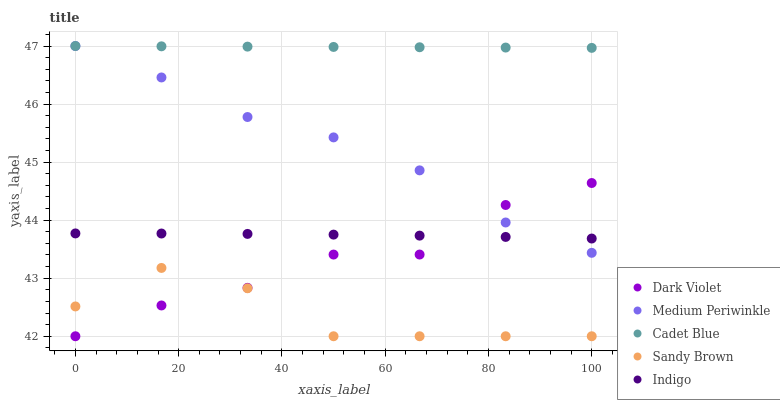Does Sandy Brown have the minimum area under the curve?
Answer yes or no. Yes. Does Cadet Blue have the maximum area under the curve?
Answer yes or no. Yes. Does Medium Periwinkle have the minimum area under the curve?
Answer yes or no. No. Does Medium Periwinkle have the maximum area under the curve?
Answer yes or no. No. Is Cadet Blue the smoothest?
Answer yes or no. Yes. Is Dark Violet the roughest?
Answer yes or no. Yes. Is Medium Periwinkle the smoothest?
Answer yes or no. No. Is Medium Periwinkle the roughest?
Answer yes or no. No. Does Sandy Brown have the lowest value?
Answer yes or no. Yes. Does Medium Periwinkle have the lowest value?
Answer yes or no. No. Does Medium Periwinkle have the highest value?
Answer yes or no. Yes. Does Dark Violet have the highest value?
Answer yes or no. No. Is Indigo less than Cadet Blue?
Answer yes or no. Yes. Is Medium Periwinkle greater than Sandy Brown?
Answer yes or no. Yes. Does Dark Violet intersect Indigo?
Answer yes or no. Yes. Is Dark Violet less than Indigo?
Answer yes or no. No. Is Dark Violet greater than Indigo?
Answer yes or no. No. Does Indigo intersect Cadet Blue?
Answer yes or no. No. 